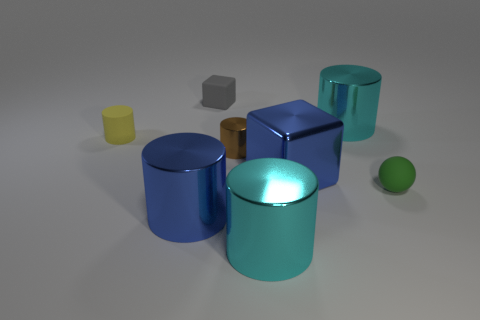If we were to categorize these objects by size, how would the categories be divided? The objects can be categorized into three size groups. The first group contains the smallest objects, which includes the yellow matte cylinder, gray cube, and green sphere. The second group is the intermediate-sized objects, represented by the small blue matte cylinder. The third group consists of the largest objects, which are the large bronze and blue shiny cylinders. 